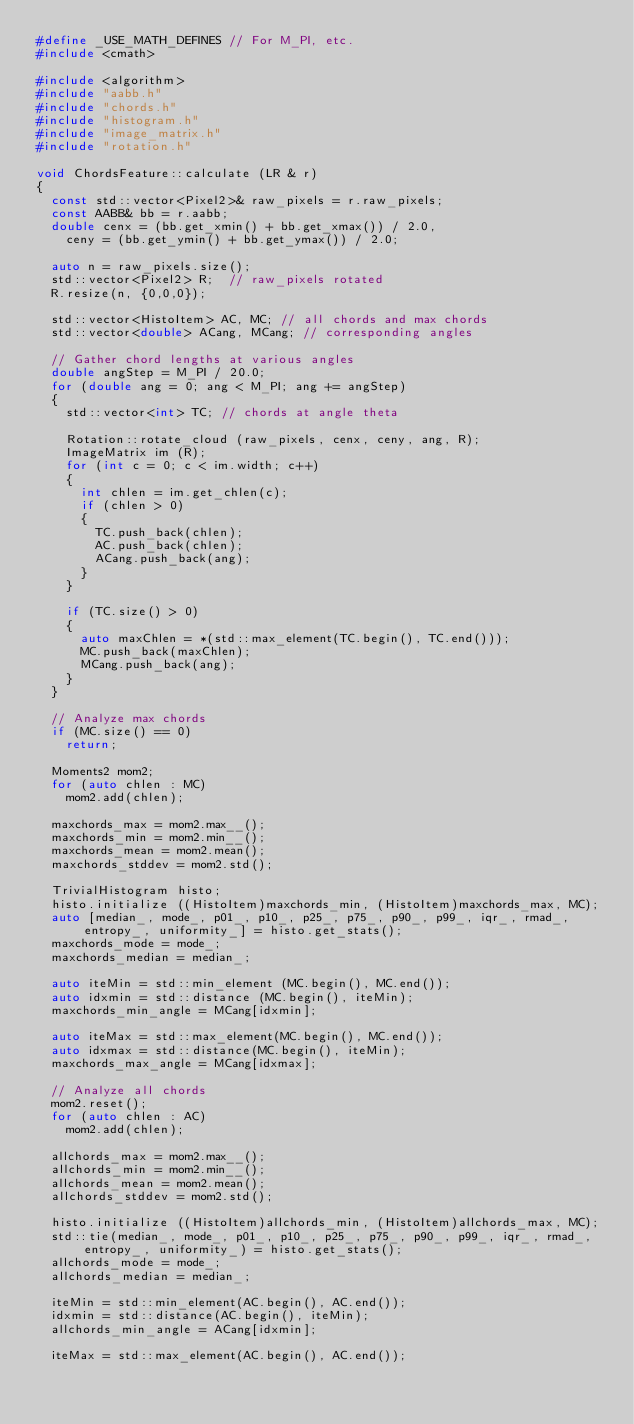<code> <loc_0><loc_0><loc_500><loc_500><_C++_>#define _USE_MATH_DEFINES	// For M_PI, etc.
#include <cmath>

#include <algorithm>
#include "aabb.h"
#include "chords.h"
#include "histogram.h"
#include "image_matrix.h"
#include "rotation.h"

void ChordsFeature::calculate (LR & r)
{
	const std::vector<Pixel2>& raw_pixels = r.raw_pixels;
	const AABB& bb = r.aabb;
	double cenx = (bb.get_xmin() + bb.get_xmax()) / 2.0,
		ceny = (bb.get_ymin() + bb.get_ymax()) / 2.0;

	auto n = raw_pixels.size();
	std::vector<Pixel2> R;	// raw_pixels rotated 
	R.resize(n, {0,0,0});

	std::vector<HistoItem> AC, MC; // all chords and max chords
	std::vector<double> ACang, MCang; // corresponding angles

	// Gather chord lengths at various angles
	double angStep = M_PI / 20.0;
	for (double ang = 0; ang < M_PI; ang += angStep)
	{
		std::vector<int> TC; // chords at angle theta

		Rotation::rotate_cloud (raw_pixels, cenx, ceny, ang, R);
		ImageMatrix im (R);
		for (int c = 0; c < im.width; c++)
		{
			int chlen = im.get_chlen(c);
			if (chlen > 0)
			{
				TC.push_back(chlen);
				AC.push_back(chlen);
				ACang.push_back(ang);
			}
		}

		if (TC.size() > 0)
		{
			auto maxChlen = *(std::max_element(TC.begin(), TC.end()));
			MC.push_back(maxChlen);
			MCang.push_back(ang);
		}
	}

	// Analyze max chords
	if (MC.size() == 0)
		return;

	Moments2 mom2;
	for (auto chlen : MC)
		mom2.add(chlen);
	
	maxchords_max = mom2.max__();
	maxchords_min = mom2.min__();
	maxchords_mean = mom2.mean();
	maxchords_stddev = mom2.std();

	TrivialHistogram histo;
	histo.initialize ((HistoItem)maxchords_min, (HistoItem)maxchords_max, MC);
	auto [median_, mode_, p01_, p10_, p25_, p75_, p90_, p99_, iqr_, rmad_, entropy_, uniformity_] = histo.get_stats();
	maxchords_mode = mode_;
	maxchords_median = median_;
	
	auto iteMin = std::min_element (MC.begin(), MC.end());
	auto idxmin = std::distance (MC.begin(), iteMin);
	maxchords_min_angle = MCang[idxmin];

	auto iteMax = std::max_element(MC.begin(), MC.end());
	auto idxmax = std::distance(MC.begin(), iteMin);
	maxchords_max_angle = MCang[idxmax];

	// Analyze all chords
	mom2.reset();
	for (auto chlen : AC)
		mom2.add(chlen);

	allchords_max = mom2.max__();
	allchords_min = mom2.min__();
	allchords_mean = mom2.mean();
	allchords_stddev = mom2.std();

	histo.initialize ((HistoItem)allchords_min, (HistoItem)allchords_max, MC);
	std::tie(median_, mode_, p01_, p10_, p25_, p75_, p90_, p99_, iqr_, rmad_, entropy_, uniformity_) = histo.get_stats();
	allchords_mode = mode_;
	allchords_median = median_;

	iteMin = std::min_element(AC.begin(), AC.end());
	idxmin = std::distance(AC.begin(), iteMin);
	allchords_min_angle = ACang[idxmin];

	iteMax = std::max_element(AC.begin(), AC.end());</code> 